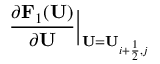Convert formula to latex. <formula><loc_0><loc_0><loc_500><loc_500>\frac { \partial F _ { 1 } ( U ) } { \partial U } \Big | _ { U = U _ { i + \frac { 1 } { 2 } , j } }</formula> 